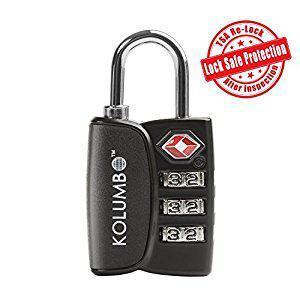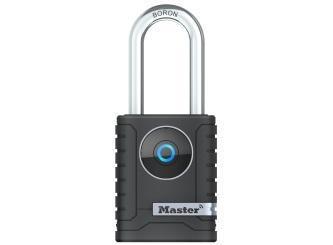The first image is the image on the left, the second image is the image on the right. Assess this claim about the two images: "One lock features a red diamond shape on the front of a lock near three vertical combination wheels.". Correct or not? Answer yes or no. Yes. The first image is the image on the left, the second image is the image on the right. Considering the images on both sides, is "At least one image is a manual mechanical combination lock with a logo design other than a blue circle." valid? Answer yes or no. Yes. The first image is the image on the left, the second image is the image on the right. For the images shown, is this caption "An image shows a lock with three rows of numbers to enter the combination." true? Answer yes or no. Yes. The first image is the image on the left, the second image is the image on the right. Assess this claim about the two images: "There is a numbered padlock in one of the images.". Correct or not? Answer yes or no. Yes. 